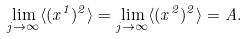<formula> <loc_0><loc_0><loc_500><loc_500>\lim _ { j \to \infty } \langle ( x ^ { 1 } ) ^ { 2 } \rangle = \lim _ { j \to \infty } \langle ( x ^ { 2 } ) ^ { 2 } \rangle = A .</formula> 